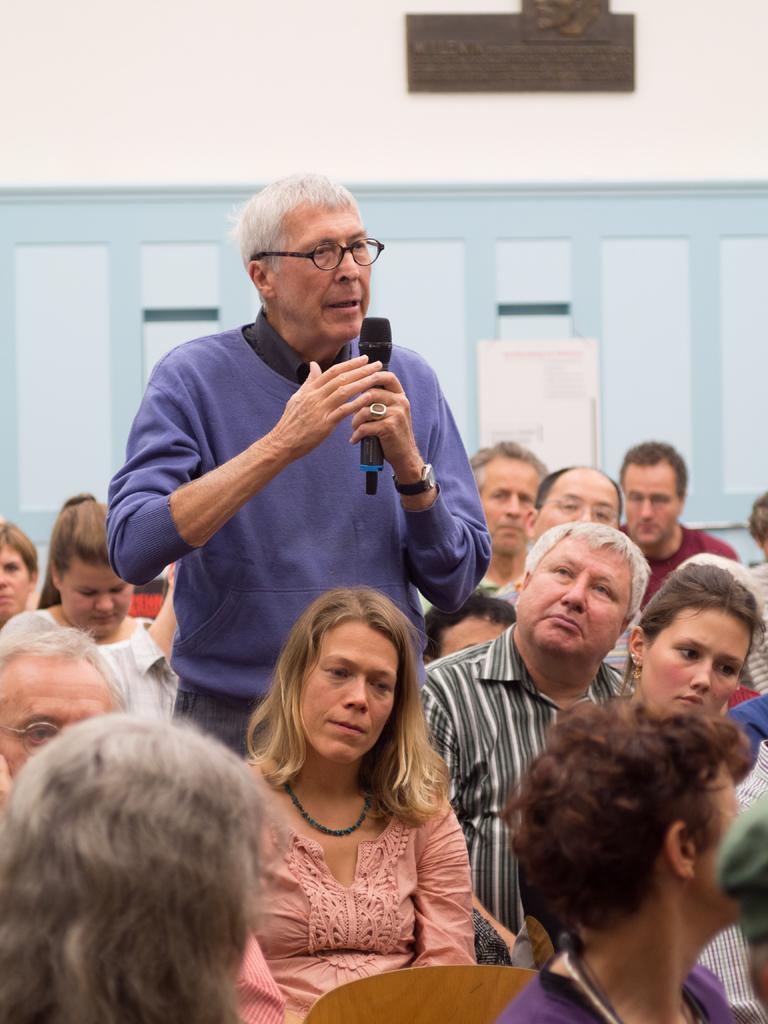In one or two sentences, can you explain what this image depicts? In this image we can see a person standing, and holding a micro phone in the hands, and in front a group of people are sitting, and at back here is the wall. 